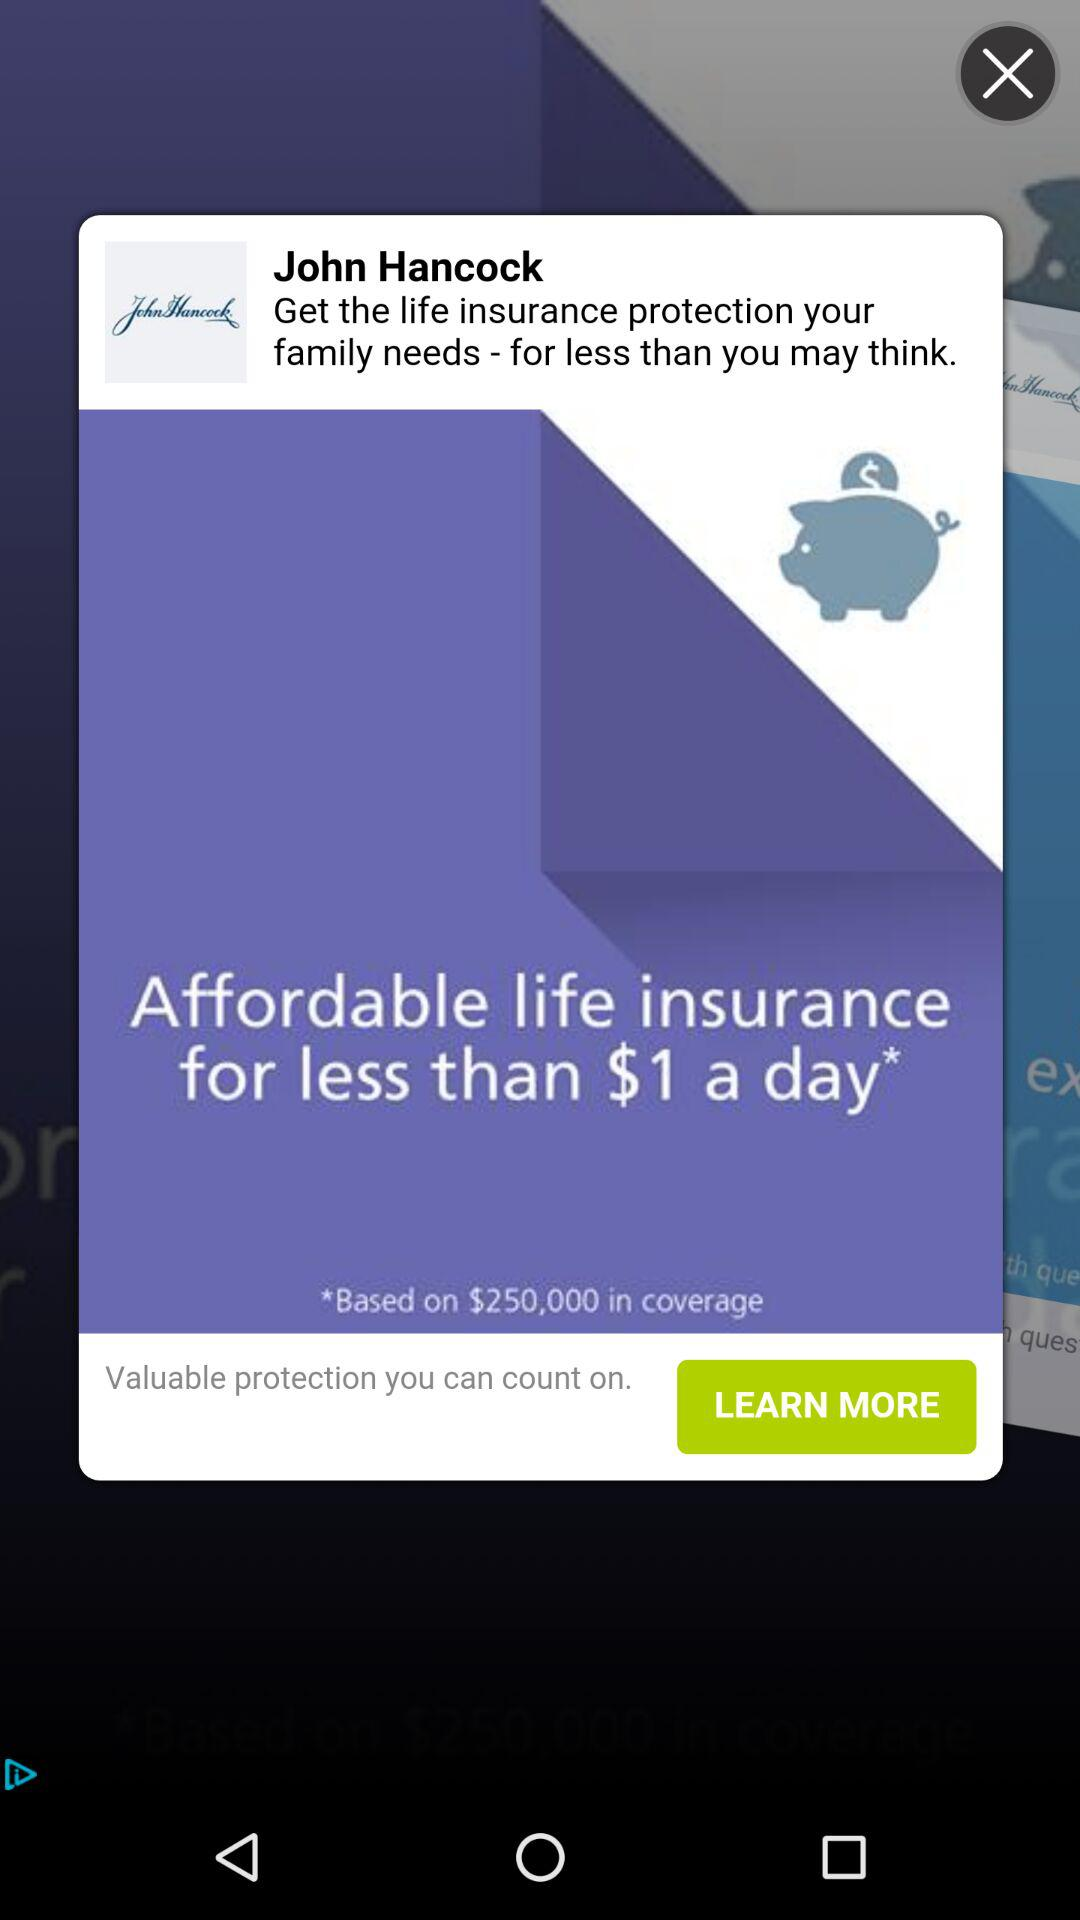How much life insurance coverage does the offer include?
Answer the question using a single word or phrase. $250,000 